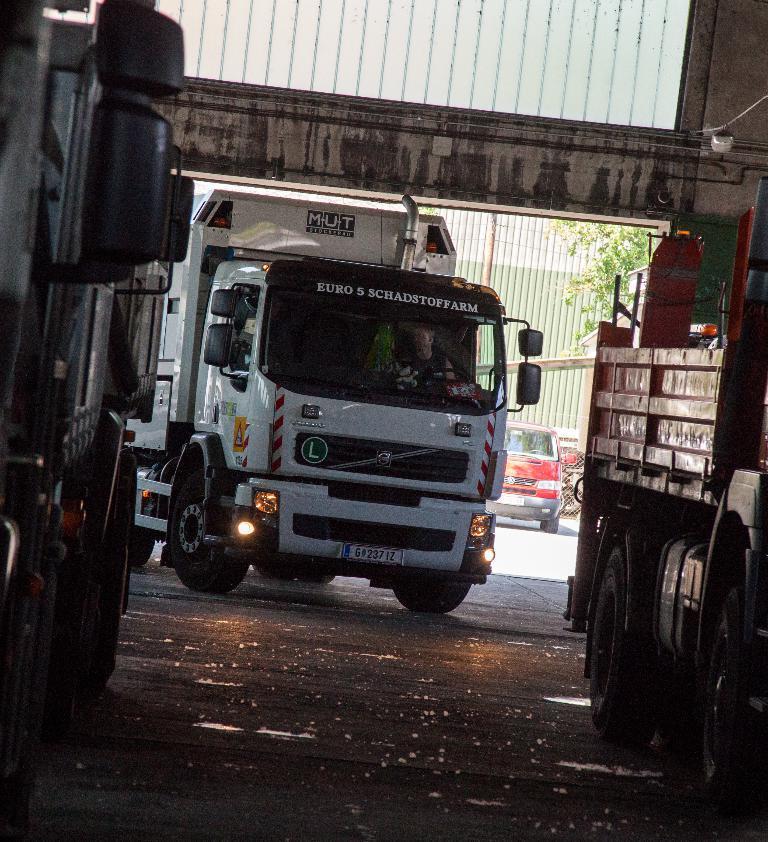Could you give a brief overview of what you see in this image? In this image there is one truck in middle of this image which is in white color. There is one other truck at left side of this image and other is at right side of this image and there is one semi truck at right side to this white colored truck and there is a building at out side to this shelter and there is a tree at middle of this image. 